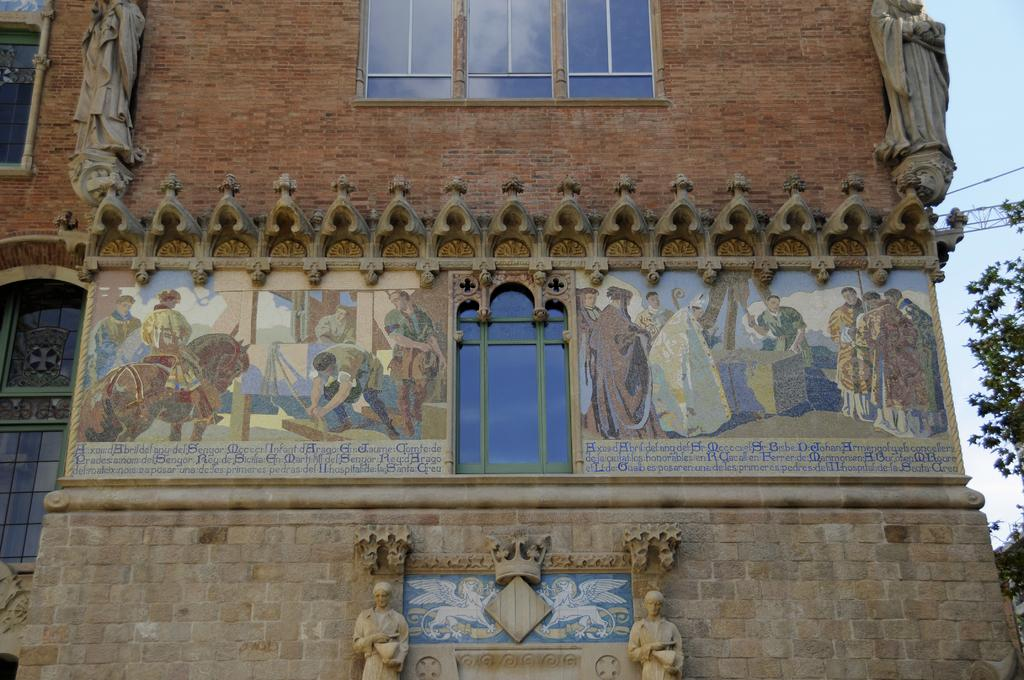What is the primary material used to construct the building in the image? The building in the image is made of red bricks. What type of decorations are on the building? There are posters of humans on the building. What can be seen in the background of the image? Trees are visible in the background of the image. Can you tell me how many times the volcano sneezes in the image? There is no volcano present in the image, so it cannot sneeze. 